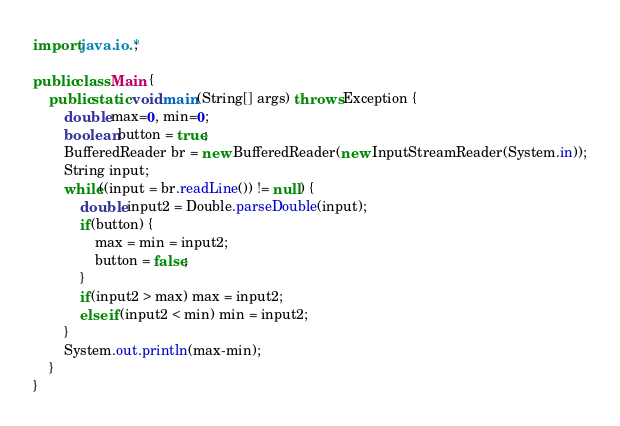Convert code to text. <code><loc_0><loc_0><loc_500><loc_500><_Java_>import java.io.*;

public class Main {
	public static void main(String[] args) throws Exception {
		double max=0, min=0;
		boolean button = true;
		BufferedReader br = new BufferedReader(new InputStreamReader(System.in));
		String input;
		while((input = br.readLine()) != null) {
			double input2 = Double.parseDouble(input);
			if(button) {
				max = min = input2;
				button = false;
			}
			if(input2 > max) max = input2;
			else if(input2 < min) min = input2;
		}
		System.out.println(max-min);
	}
}</code> 